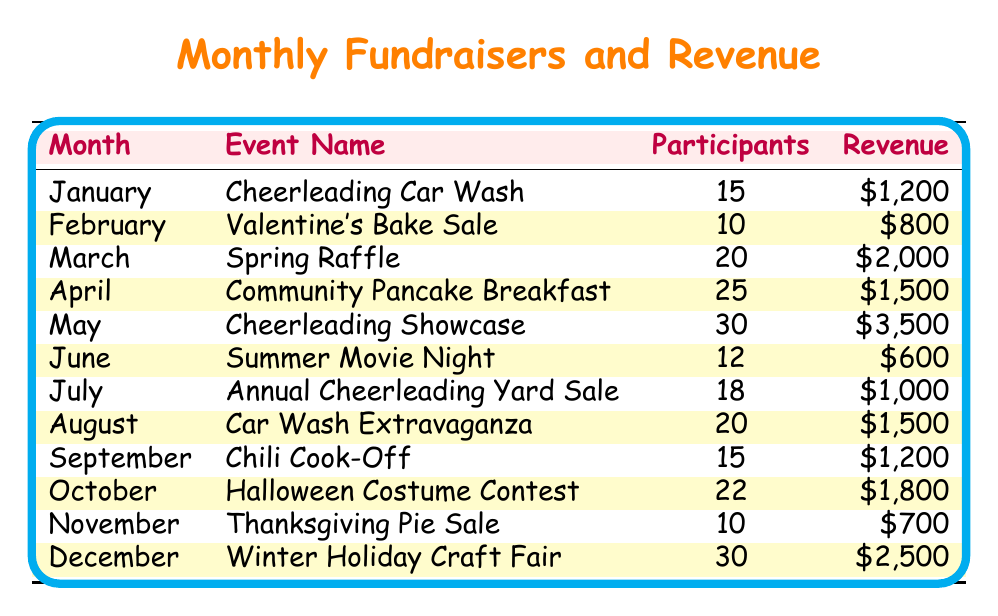What event generated the highest revenue in May? The table indicates that the event in May was the "Cheerleading Showcase" with a revenue of $3,500, which is the highest compared to other months.
Answer: Cheerleading Showcase How many participants were there at the Valentine's Bake Sale? According to the table, the number of participants at the Valentine's Bake Sale in February was 10.
Answer: 10 What was the total revenue generated from the car wash events? There are two car wash events listed: "Cheerleading Car Wash" in January generating $1,200 and "Car Wash Extravaganza" in August generating $1,500. Adding these two amounts gives $1,200 + $1,500 = $2,700.
Answer: $2,700 Which event had the least number of participants? In the table, the event with the least number of participants is the "Summer Movie Night" in June, with just 12 participants.
Answer: Summer Movie Night Did the revenue from the Halloween Costume Contest exceed $1,500? The table shows that the revenue for the Halloween Costume Contest in October was $1,800, which is indeed more than $1,500.
Answer: Yes What is the average revenue generated across all events? To find the average revenue, first, we sum all revenues: $1,200 + $800 + $2,000 + $1,500 + $3,500 + $600 + $1,000 + $1,500 + $1,200 + $1,800 + $700 + $2,500 = $18,300. There are 12 events, so we divide $18,300 by 12, resulting in an average of $1,525.
Answer: $1,525 Which months had revenues below $1,000? Looking at the table, the events with revenues below $1,000 were "Valentine's Bake Sale" in February ($800), "Summer Movie Night" in June ($600), and "Thanksgiving Pie Sale" in November ($700).
Answer: February, June, November How many events had more than 20 participants? The table lists three events with more than 20 participants: "Community Pancake Breakfast" in April (25 participants), "Cheerleading Showcase" in May (30 participants), and "Winter Holiday Craft Fair" in December (30 participants). Hence, there are three such events.
Answer: 3 What was the total revenue generated during the last quarter of the year? The last quarter includes October, November, and December. The revenues for these months are: October ($1,800), November ($700), and December ($2,500). Summing these values gives $1,800 + $700 + $2,500 = $5,000.
Answer: $5,000 How many months had events that generated revenue above $1,500? By analyzing the table, the months with revenues above $1,500 are May ($3,500), October ($1,800), and December ($2,500). This amounts to three months.
Answer: 3 Was the revenue from the "Cheerleading Showcase" the highest revenue of the year? Since the revenue generated from the "Cheerleading Showcase" in May was $3,500, it can be confirmed by checking the revenues of all other months, making this the highest for the year.
Answer: Yes 